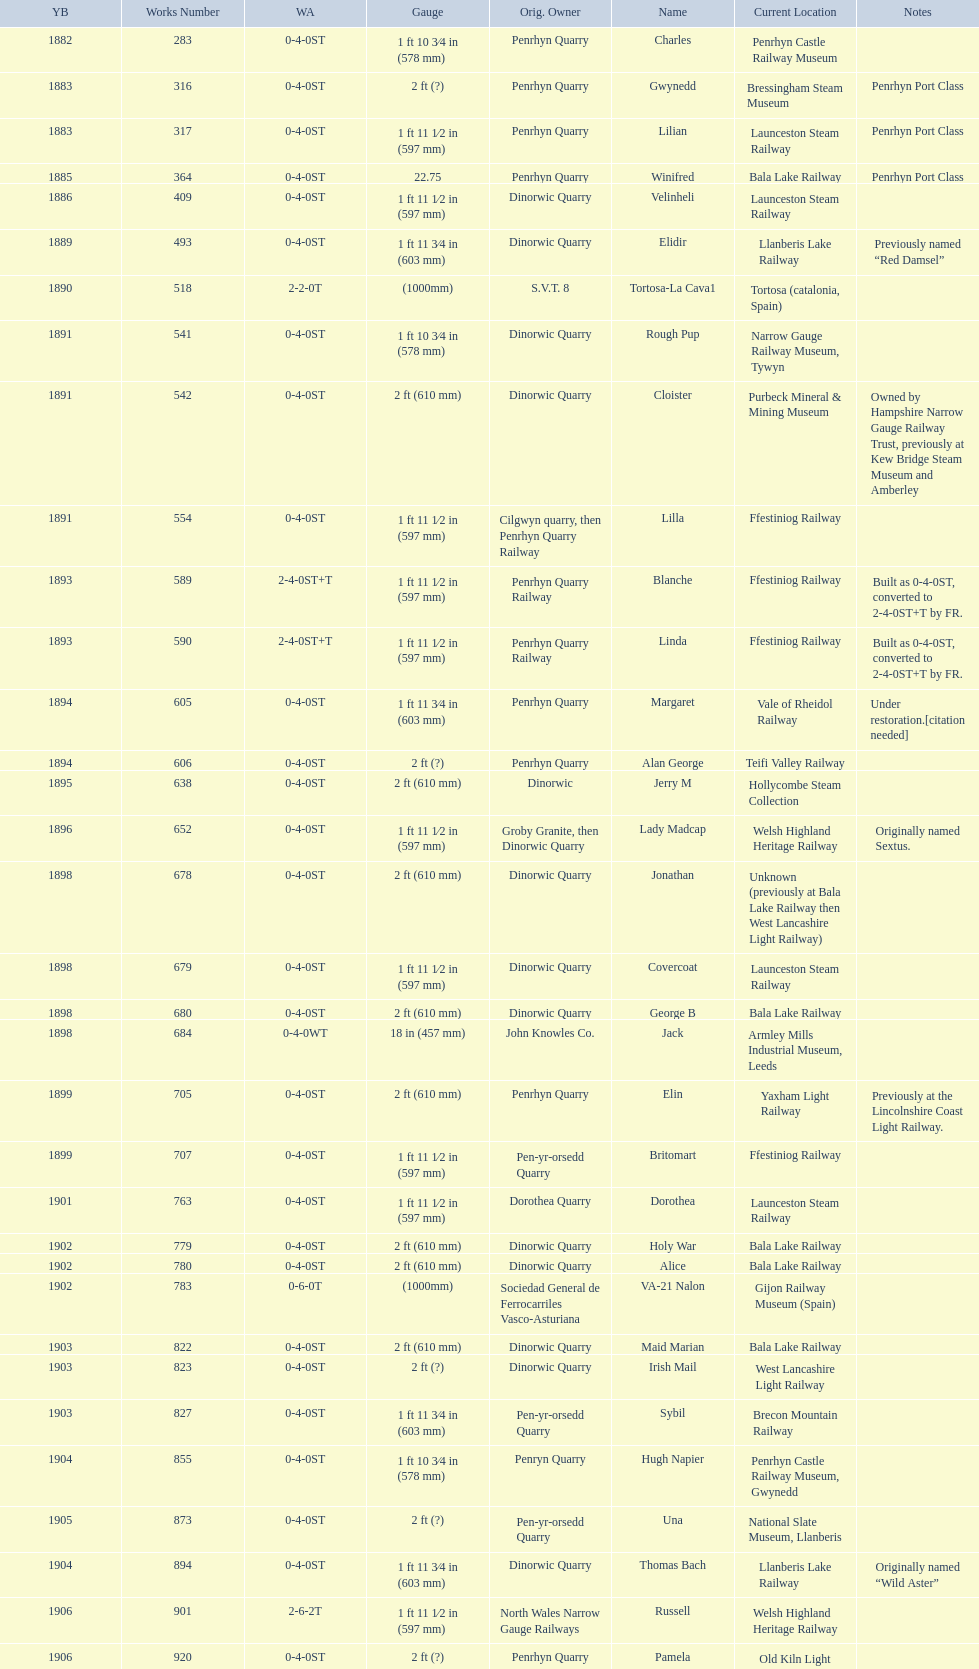After 1940, how many steam locomotives were built? 2. 